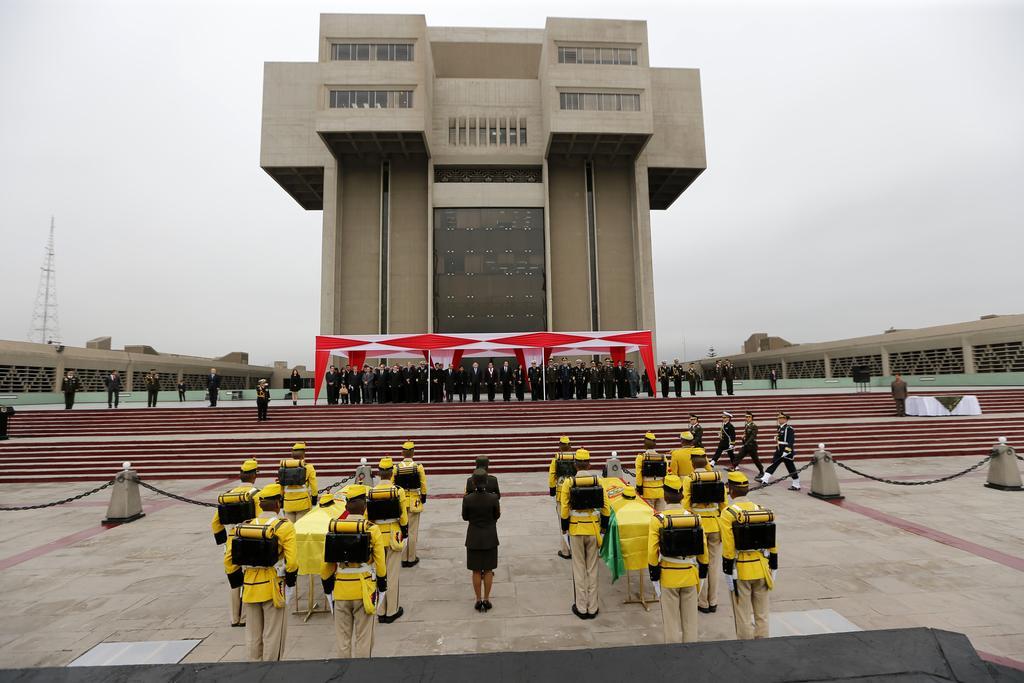Describe this image in one or two sentences. In the center of the image we can see a few people are standing. Among them, we can see a few people are wearing caps and some objects. Between them, we can see some objects. In the background, we can see the sky, one building, one pole type structure, staircase, few people are standing and a few other objects. 